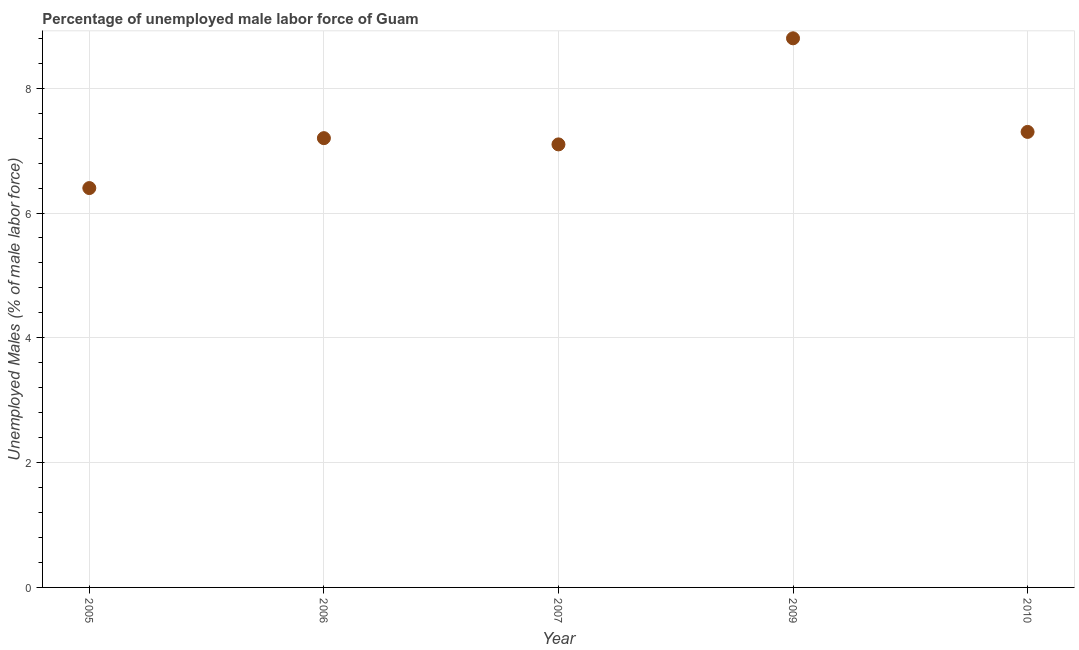What is the total unemployed male labour force in 2009?
Provide a short and direct response. 8.8. Across all years, what is the maximum total unemployed male labour force?
Give a very brief answer. 8.8. Across all years, what is the minimum total unemployed male labour force?
Your response must be concise. 6.4. In which year was the total unemployed male labour force maximum?
Your answer should be compact. 2009. In which year was the total unemployed male labour force minimum?
Your answer should be compact. 2005. What is the sum of the total unemployed male labour force?
Give a very brief answer. 36.8. What is the difference between the total unemployed male labour force in 2005 and 2009?
Provide a short and direct response. -2.4. What is the average total unemployed male labour force per year?
Make the answer very short. 7.36. What is the median total unemployed male labour force?
Provide a succinct answer. 7.2. In how many years, is the total unemployed male labour force greater than 5.6 %?
Keep it short and to the point. 5. Do a majority of the years between 2007 and 2006 (inclusive) have total unemployed male labour force greater than 3.2 %?
Offer a very short reply. No. What is the ratio of the total unemployed male labour force in 2006 to that in 2007?
Provide a short and direct response. 1.01. Is the difference between the total unemployed male labour force in 2009 and 2010 greater than the difference between any two years?
Give a very brief answer. No. What is the difference between the highest and the second highest total unemployed male labour force?
Make the answer very short. 1.5. Is the sum of the total unemployed male labour force in 2006 and 2007 greater than the maximum total unemployed male labour force across all years?
Your response must be concise. Yes. What is the difference between the highest and the lowest total unemployed male labour force?
Ensure brevity in your answer.  2.4. What is the difference between two consecutive major ticks on the Y-axis?
Keep it short and to the point. 2. What is the title of the graph?
Provide a succinct answer. Percentage of unemployed male labor force of Guam. What is the label or title of the X-axis?
Provide a succinct answer. Year. What is the label or title of the Y-axis?
Offer a terse response. Unemployed Males (% of male labor force). What is the Unemployed Males (% of male labor force) in 2005?
Make the answer very short. 6.4. What is the Unemployed Males (% of male labor force) in 2006?
Offer a terse response. 7.2. What is the Unemployed Males (% of male labor force) in 2007?
Give a very brief answer. 7.1. What is the Unemployed Males (% of male labor force) in 2009?
Provide a succinct answer. 8.8. What is the Unemployed Males (% of male labor force) in 2010?
Offer a terse response. 7.3. What is the difference between the Unemployed Males (% of male labor force) in 2005 and 2007?
Your response must be concise. -0.7. What is the difference between the Unemployed Males (% of male labor force) in 2005 and 2009?
Provide a short and direct response. -2.4. What is the difference between the Unemployed Males (% of male labor force) in 2005 and 2010?
Your answer should be very brief. -0.9. What is the difference between the Unemployed Males (% of male labor force) in 2006 and 2009?
Your answer should be compact. -1.6. What is the difference between the Unemployed Males (% of male labor force) in 2007 and 2009?
Make the answer very short. -1.7. What is the difference between the Unemployed Males (% of male labor force) in 2007 and 2010?
Keep it short and to the point. -0.2. What is the difference between the Unemployed Males (% of male labor force) in 2009 and 2010?
Give a very brief answer. 1.5. What is the ratio of the Unemployed Males (% of male labor force) in 2005 to that in 2006?
Give a very brief answer. 0.89. What is the ratio of the Unemployed Males (% of male labor force) in 2005 to that in 2007?
Ensure brevity in your answer.  0.9. What is the ratio of the Unemployed Males (% of male labor force) in 2005 to that in 2009?
Ensure brevity in your answer.  0.73. What is the ratio of the Unemployed Males (% of male labor force) in 2005 to that in 2010?
Your response must be concise. 0.88. What is the ratio of the Unemployed Males (% of male labor force) in 2006 to that in 2009?
Your answer should be very brief. 0.82. What is the ratio of the Unemployed Males (% of male labor force) in 2006 to that in 2010?
Provide a short and direct response. 0.99. What is the ratio of the Unemployed Males (% of male labor force) in 2007 to that in 2009?
Provide a succinct answer. 0.81. What is the ratio of the Unemployed Males (% of male labor force) in 2009 to that in 2010?
Your answer should be compact. 1.21. 